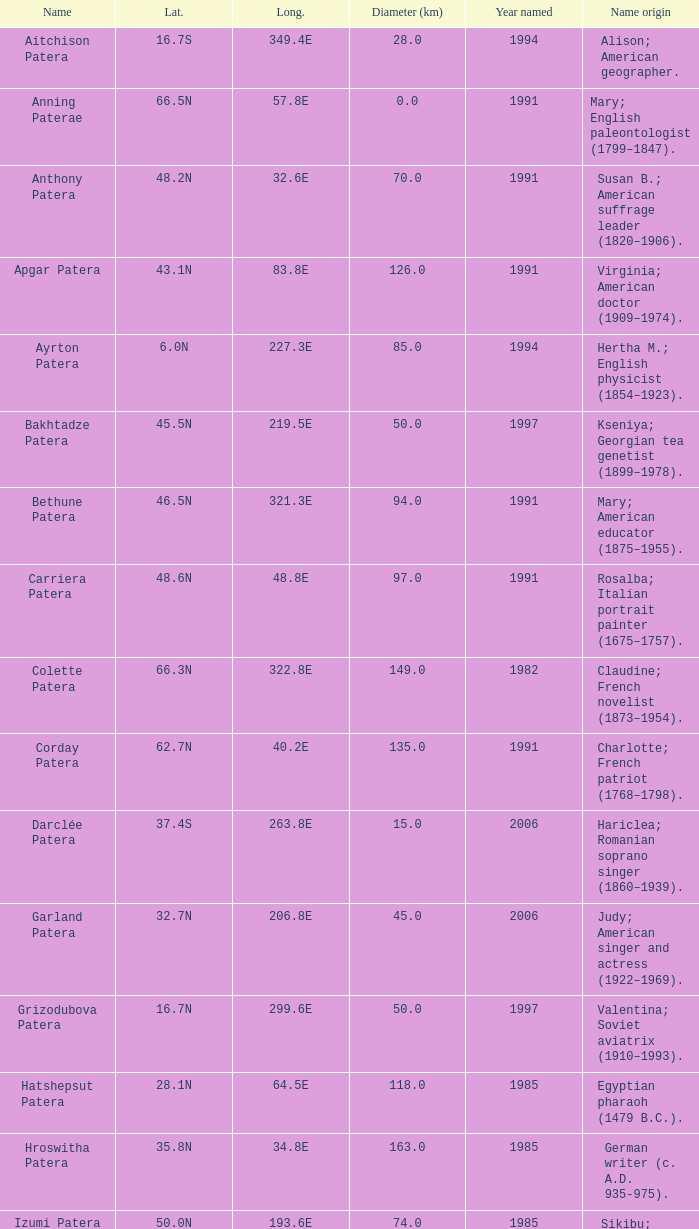What is the longitude of the feature named Razia Patera?  197.8E. 